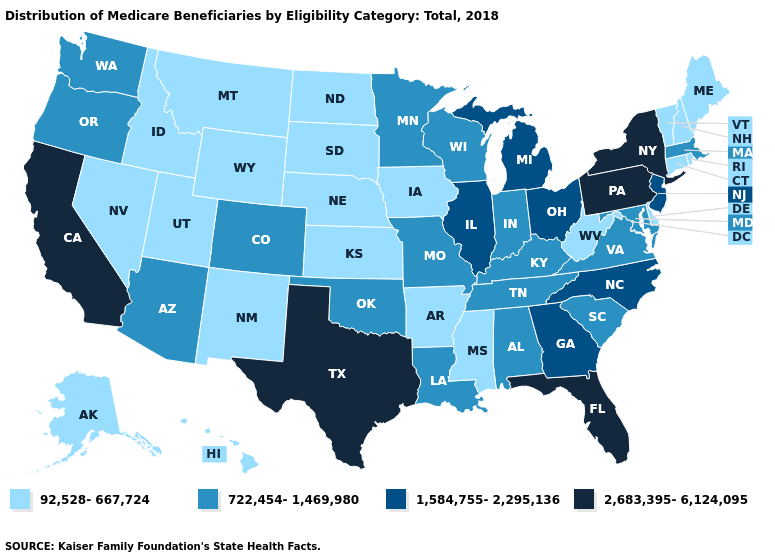Name the states that have a value in the range 92,528-667,724?
Write a very short answer. Alaska, Arkansas, Connecticut, Delaware, Hawaii, Idaho, Iowa, Kansas, Maine, Mississippi, Montana, Nebraska, Nevada, New Hampshire, New Mexico, North Dakota, Rhode Island, South Dakota, Utah, Vermont, West Virginia, Wyoming. Among the states that border West Virginia , does Ohio have the lowest value?
Short answer required. No. What is the value of Maine?
Be succinct. 92,528-667,724. Does Washington have the same value as Maryland?
Quick response, please. Yes. Does Indiana have the lowest value in the MidWest?
Give a very brief answer. No. Name the states that have a value in the range 1,584,755-2,295,136?
Be succinct. Georgia, Illinois, Michigan, New Jersey, North Carolina, Ohio. Name the states that have a value in the range 2,683,395-6,124,095?
Quick response, please. California, Florida, New York, Pennsylvania, Texas. What is the value of Washington?
Answer briefly. 722,454-1,469,980. Does Maryland have the highest value in the USA?
Answer briefly. No. Is the legend a continuous bar?
Answer briefly. No. Does the first symbol in the legend represent the smallest category?
Short answer required. Yes. Name the states that have a value in the range 2,683,395-6,124,095?
Give a very brief answer. California, Florida, New York, Pennsylvania, Texas. Does the map have missing data?
Concise answer only. No. Does Mississippi have a lower value than Wyoming?
Give a very brief answer. No. Does Ohio have a higher value than Maine?
Be succinct. Yes. 